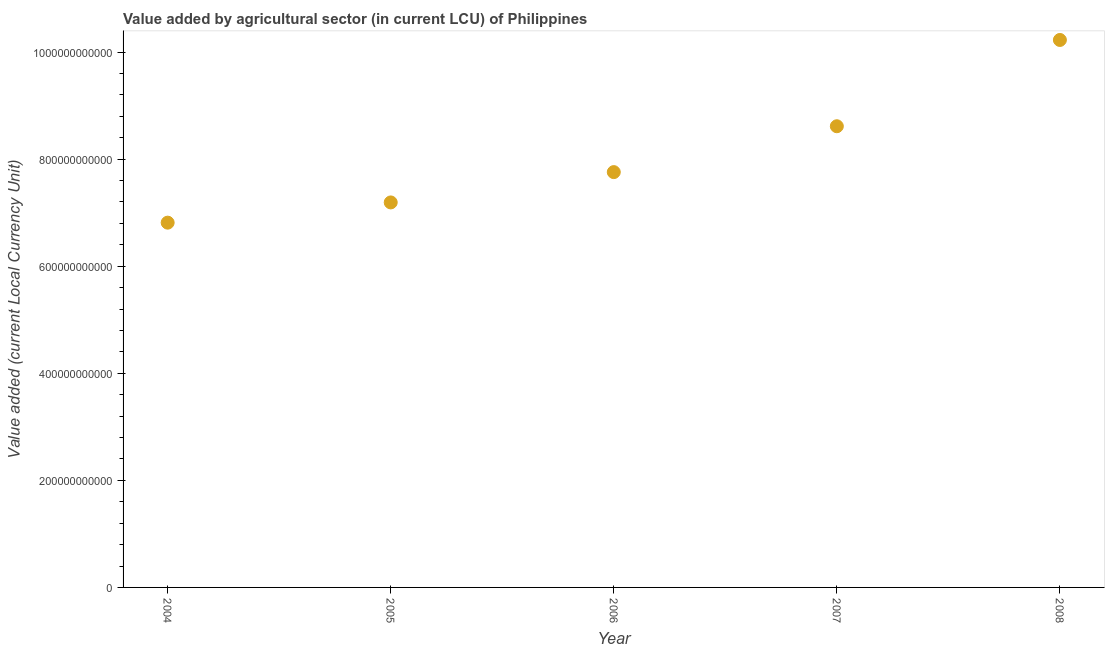What is the value added by agriculture sector in 2004?
Provide a short and direct response. 6.81e+11. Across all years, what is the maximum value added by agriculture sector?
Ensure brevity in your answer.  1.02e+12. Across all years, what is the minimum value added by agriculture sector?
Make the answer very short. 6.81e+11. In which year was the value added by agriculture sector minimum?
Your answer should be compact. 2004. What is the sum of the value added by agriculture sector?
Your response must be concise. 4.06e+12. What is the difference between the value added by agriculture sector in 2004 and 2008?
Your response must be concise. -3.41e+11. What is the average value added by agriculture sector per year?
Make the answer very short. 8.12e+11. What is the median value added by agriculture sector?
Give a very brief answer. 7.76e+11. In how many years, is the value added by agriculture sector greater than 960000000000 LCU?
Your response must be concise. 1. Do a majority of the years between 2004 and 2008 (inclusive) have value added by agriculture sector greater than 160000000000 LCU?
Make the answer very short. Yes. What is the ratio of the value added by agriculture sector in 2005 to that in 2007?
Provide a short and direct response. 0.83. What is the difference between the highest and the second highest value added by agriculture sector?
Make the answer very short. 1.61e+11. Is the sum of the value added by agriculture sector in 2004 and 2007 greater than the maximum value added by agriculture sector across all years?
Offer a terse response. Yes. What is the difference between the highest and the lowest value added by agriculture sector?
Your answer should be compact. 3.41e+11. Does the value added by agriculture sector monotonically increase over the years?
Keep it short and to the point. Yes. What is the difference between two consecutive major ticks on the Y-axis?
Offer a very short reply. 2.00e+11. What is the title of the graph?
Give a very brief answer. Value added by agricultural sector (in current LCU) of Philippines. What is the label or title of the Y-axis?
Make the answer very short. Value added (current Local Currency Unit). What is the Value added (current Local Currency Unit) in 2004?
Your response must be concise. 6.81e+11. What is the Value added (current Local Currency Unit) in 2005?
Give a very brief answer. 7.19e+11. What is the Value added (current Local Currency Unit) in 2006?
Offer a very short reply. 7.76e+11. What is the Value added (current Local Currency Unit) in 2007?
Provide a succinct answer. 8.61e+11. What is the Value added (current Local Currency Unit) in 2008?
Ensure brevity in your answer.  1.02e+12. What is the difference between the Value added (current Local Currency Unit) in 2004 and 2005?
Ensure brevity in your answer.  -3.78e+1. What is the difference between the Value added (current Local Currency Unit) in 2004 and 2006?
Make the answer very short. -9.44e+1. What is the difference between the Value added (current Local Currency Unit) in 2004 and 2007?
Ensure brevity in your answer.  -1.80e+11. What is the difference between the Value added (current Local Currency Unit) in 2004 and 2008?
Ensure brevity in your answer.  -3.41e+11. What is the difference between the Value added (current Local Currency Unit) in 2005 and 2006?
Provide a succinct answer. -5.66e+1. What is the difference between the Value added (current Local Currency Unit) in 2005 and 2007?
Make the answer very short. -1.42e+11. What is the difference between the Value added (current Local Currency Unit) in 2005 and 2008?
Your response must be concise. -3.03e+11. What is the difference between the Value added (current Local Currency Unit) in 2006 and 2007?
Keep it short and to the point. -8.57e+1. What is the difference between the Value added (current Local Currency Unit) in 2006 and 2008?
Provide a succinct answer. -2.47e+11. What is the difference between the Value added (current Local Currency Unit) in 2007 and 2008?
Offer a terse response. -1.61e+11. What is the ratio of the Value added (current Local Currency Unit) in 2004 to that in 2005?
Provide a short and direct response. 0.95. What is the ratio of the Value added (current Local Currency Unit) in 2004 to that in 2006?
Make the answer very short. 0.88. What is the ratio of the Value added (current Local Currency Unit) in 2004 to that in 2007?
Your response must be concise. 0.79. What is the ratio of the Value added (current Local Currency Unit) in 2004 to that in 2008?
Provide a succinct answer. 0.67. What is the ratio of the Value added (current Local Currency Unit) in 2005 to that in 2006?
Provide a short and direct response. 0.93. What is the ratio of the Value added (current Local Currency Unit) in 2005 to that in 2007?
Give a very brief answer. 0.83. What is the ratio of the Value added (current Local Currency Unit) in 2005 to that in 2008?
Your answer should be very brief. 0.7. What is the ratio of the Value added (current Local Currency Unit) in 2006 to that in 2007?
Your response must be concise. 0.9. What is the ratio of the Value added (current Local Currency Unit) in 2006 to that in 2008?
Your answer should be very brief. 0.76. What is the ratio of the Value added (current Local Currency Unit) in 2007 to that in 2008?
Your answer should be very brief. 0.84. 